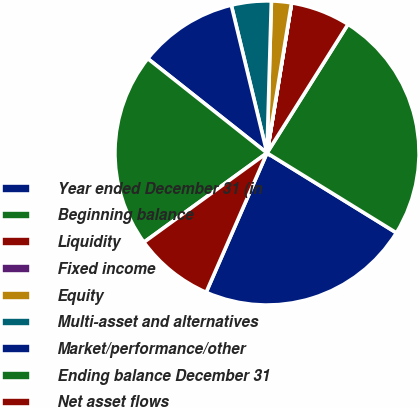Convert chart to OTSL. <chart><loc_0><loc_0><loc_500><loc_500><pie_chart><fcel>Year ended December 31 (in<fcel>Beginning balance<fcel>Liquidity<fcel>Fixed income<fcel>Equity<fcel>Multi-asset and alternatives<fcel>Market/performance/other<fcel>Ending balance December 31<fcel>Net asset flows<nl><fcel>22.75%<fcel>24.86%<fcel>6.35%<fcel>0.01%<fcel>2.12%<fcel>4.23%<fcel>10.57%<fcel>20.64%<fcel>8.46%<nl></chart> 